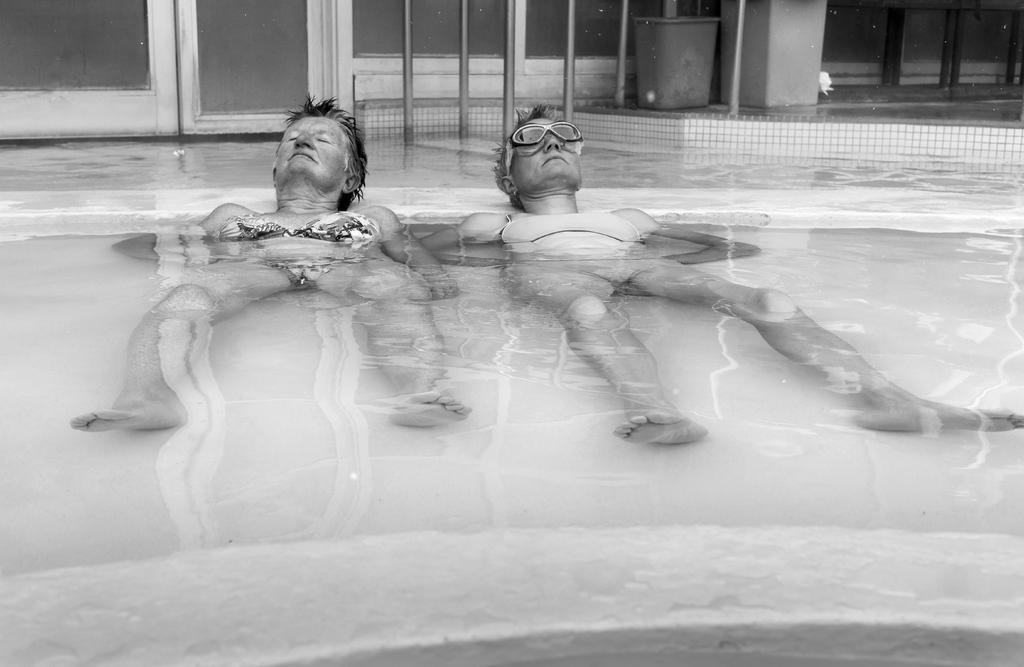In one or two sentences, can you explain what this image depicts? In this image in the middle there are two persons lying in the water, at the top there is a bucket, poles, pillar, window visible. 